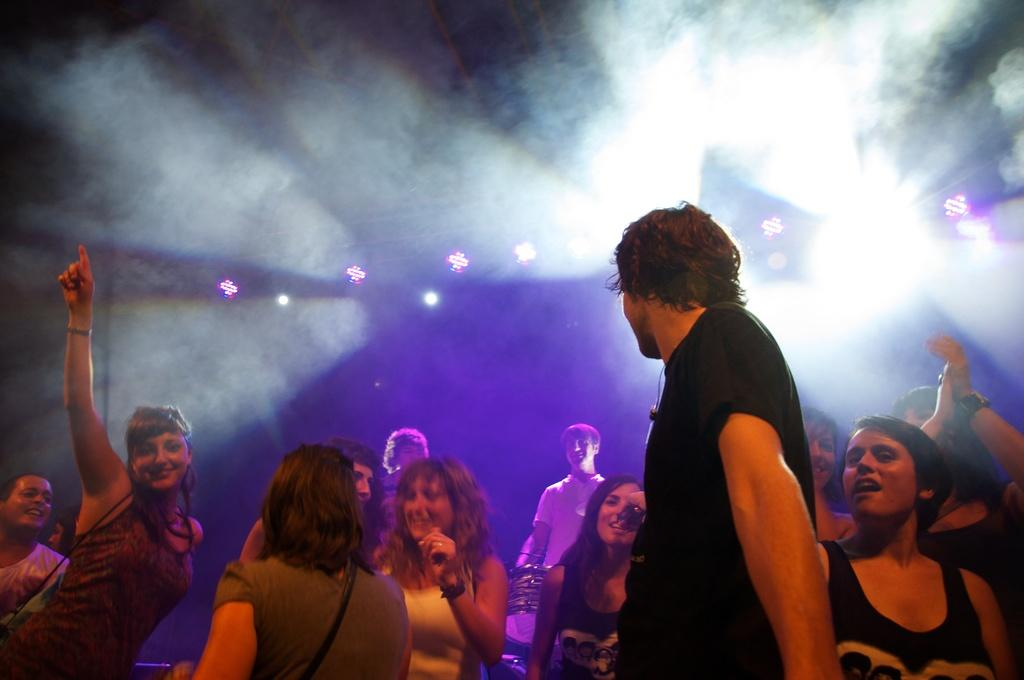How many people are in the image? There is a group of people in the image. What are the people doing in the image? The people are standing and smiling. What objects can be seen in the image besides the people? There are drums, a bag, and lights in the image. How would you describe the lighting conditions in the image? The background of the image is dark. What type of observation is the lawyer making in the image? There is no lawyer present in the image, and therefore no observation can be attributed to a lawyer. 